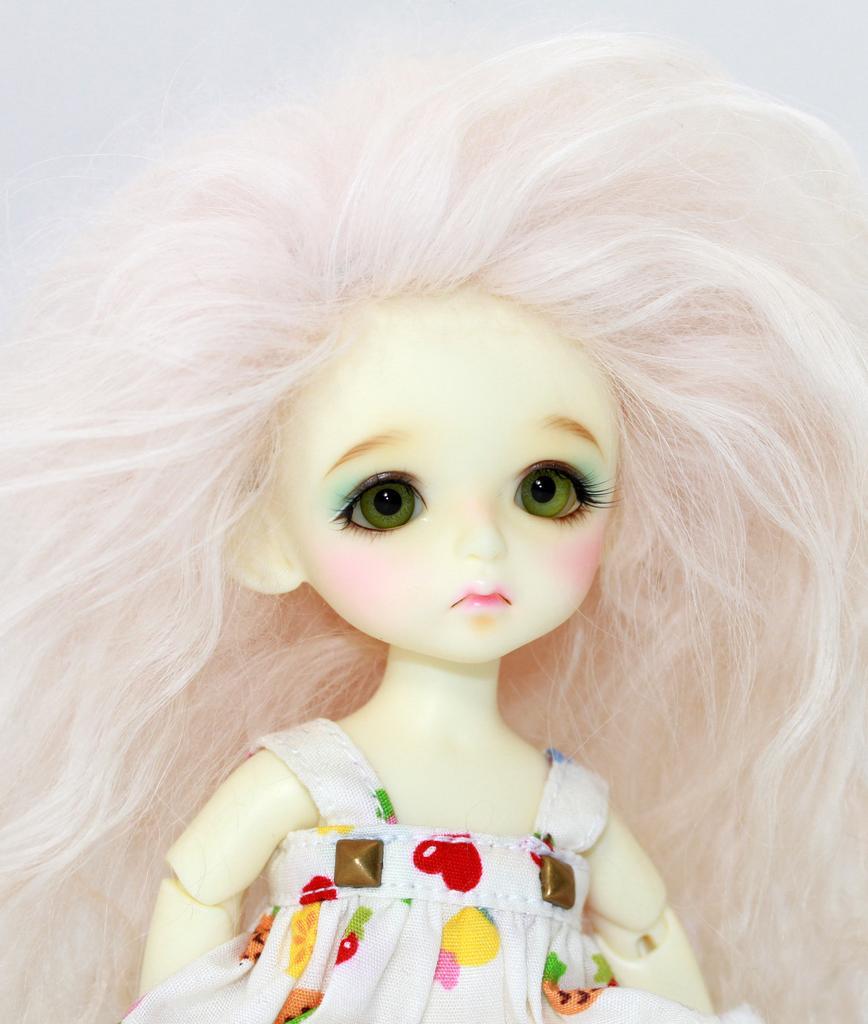In one or two sentences, can you explain what this image depicts? In the image we can see a doll, wearing clothes and the background is white. 